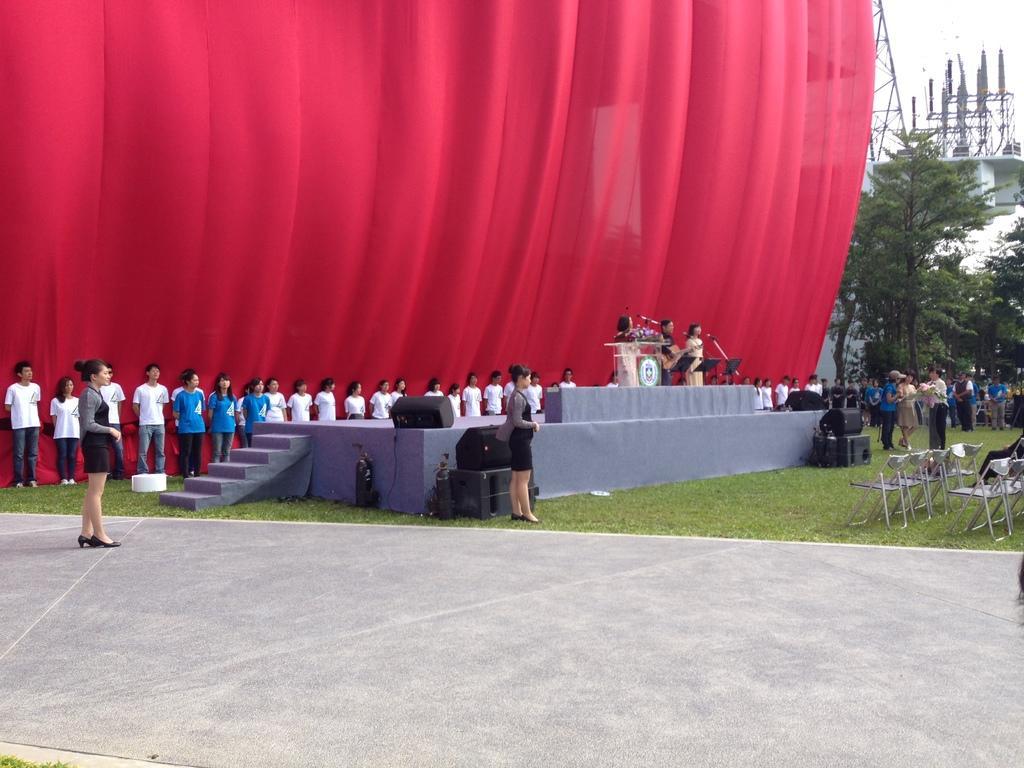Can you describe this image briefly? In this image we can see many people standing. There is a stage. Near to the stage there are steps. On the stage there are speakers. On the stage there is a podium. Few people are standing. There are mics with stands. Near to the stage there are speakers. On the ground there is grass. Also there are chairs. In the back there is a red cloth. And there are trees. 